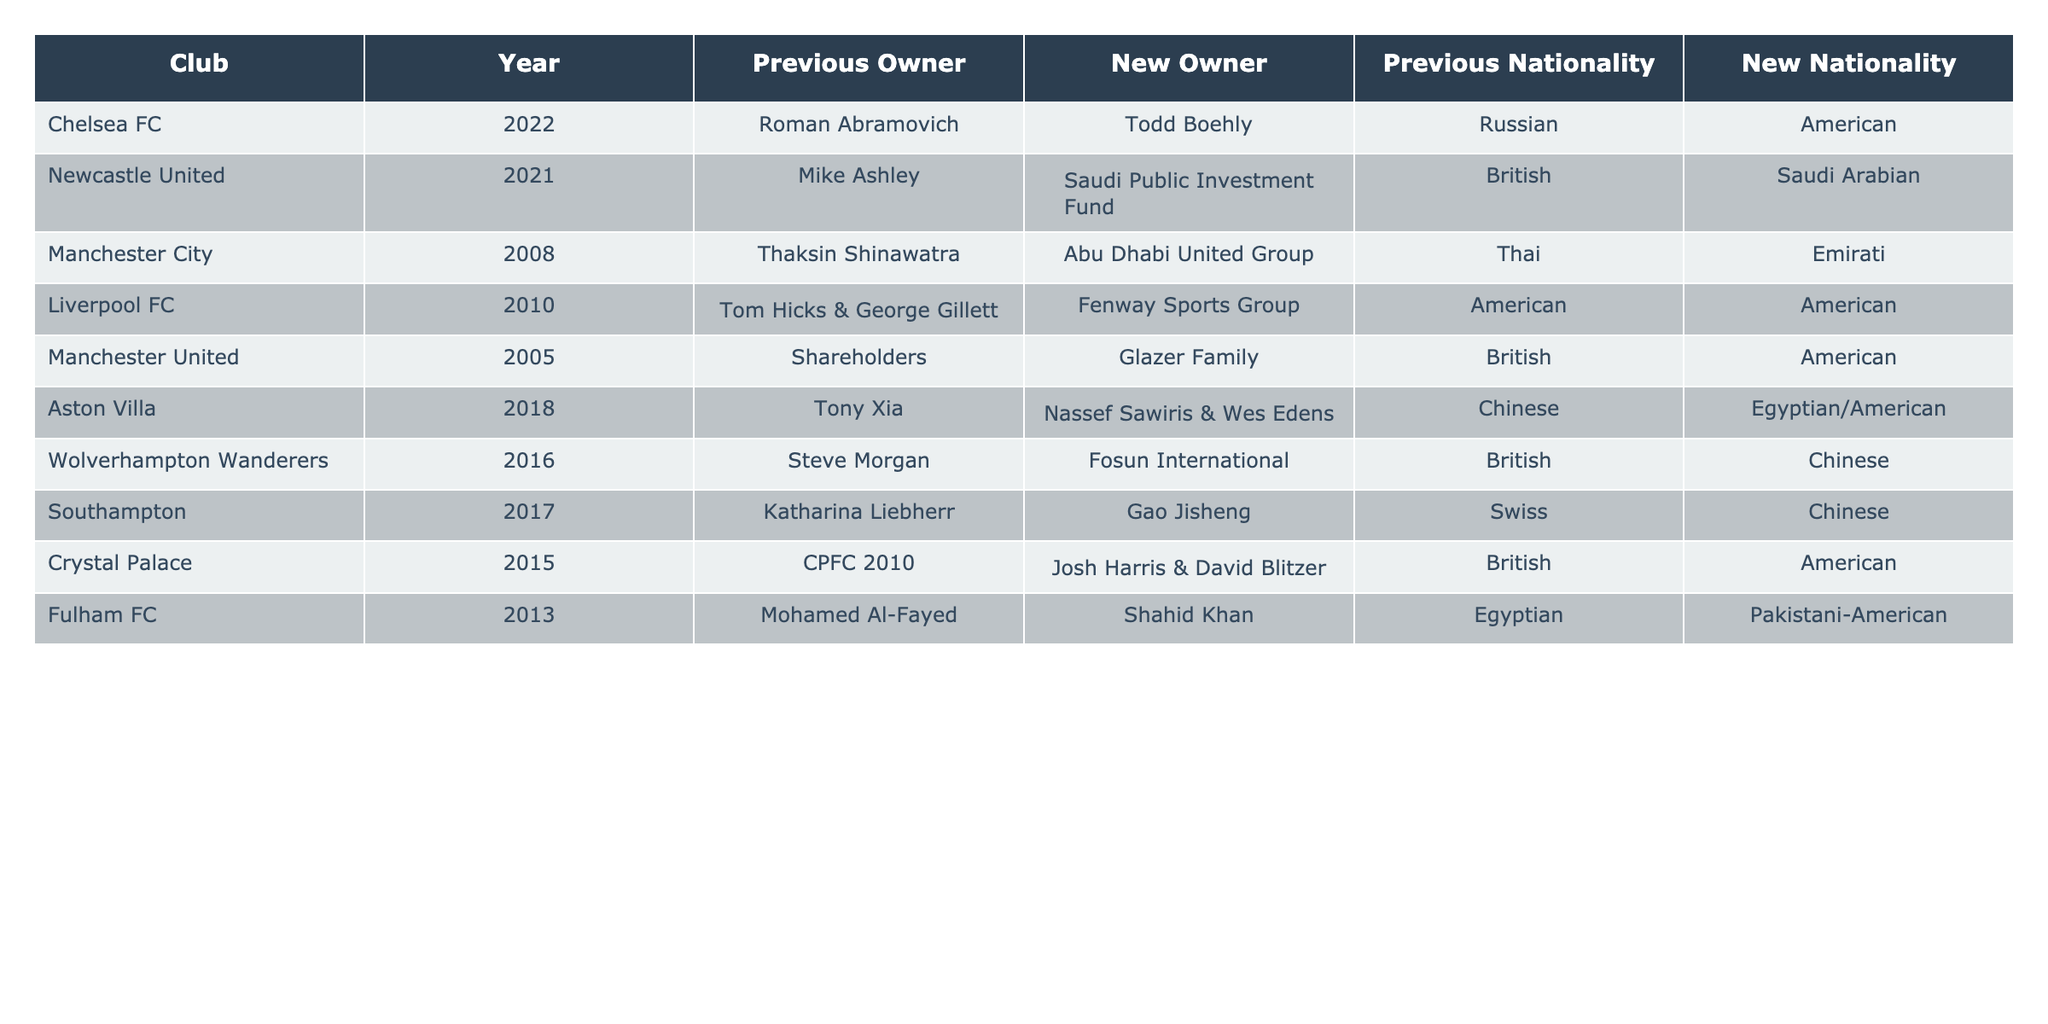What club changed ownership in 2022? The table lists Chelsea FC as the club that changed ownership in 2022, with Todd Boehly being the new owner.
Answer: Chelsea FC Which club experienced a change of ownership from a British owner to a Saudi Arabian owner? Newcastle United had a change of ownership in 2021 from Mike Ashley, a British owner, to the Saudi Public Investment Fund, which is Saudi Arabian.
Answer: Newcastle United How many clubs had American owners as of their latest ownership change? The table shows that Liverpool FC and Fulham FC had American owners at the time of their respective ownership changes. Therefore, there are two clubs in this category.
Answer: 2 Did any club switch from a national owner to an international one? Yes, Newcastle United switched from a British owner, Mike Ashley, to the Saudi Public Investment Fund, which represents a different nationality.
Answer: Yes Which club's ownership changed from a Chinese owner to an Egyptian/American ownership? Aston Villa changed from Tony Xia, a Chinese owner, to Nassef Sawiris & Wes Edens, whose nationalities are Egyptian and American.
Answer: Aston Villa What is the nationality of the new owner of Chelsea FC? Todd Boehly, the new owner of Chelsea FC since 2022, is American.
Answer: American Determine the ownership nationality of Southampton after its 2017 ownership change. After the 2017 change, Southampton's new owner, Gao Jisheng, is Chinese. Therefore, their ownership nationality changed to Chinese.
Answer: Chinese Count how many clubs in the table had their ownership transition to ownership from an Emirati group. The only club with ownership transitioning to an Emirati group is Manchester City, which changed to the Abu Dhabi United Group in 2008. Thus, there is one club.
Answer: 1 What percentage of clubs listed in the table changed to owners from Asian countries (China, Saudi Arabia, Emirati)? The clubs that changed to owners from Asian countries include Newcastle United (Saudi Arabian), Aston Villa (Egyptian/American with Egyptian roots), and Wolverhampton Wanderers (Chinese). There are 3 out of a total of 10 clubs listed, giving us a percentage of 30%.
Answer: 30% Identify which owner owned Manchester United before the Glazer Family. Manchester United was owned by shareholders before the Glazer Family took over in 2005.
Answer: Shareholders 